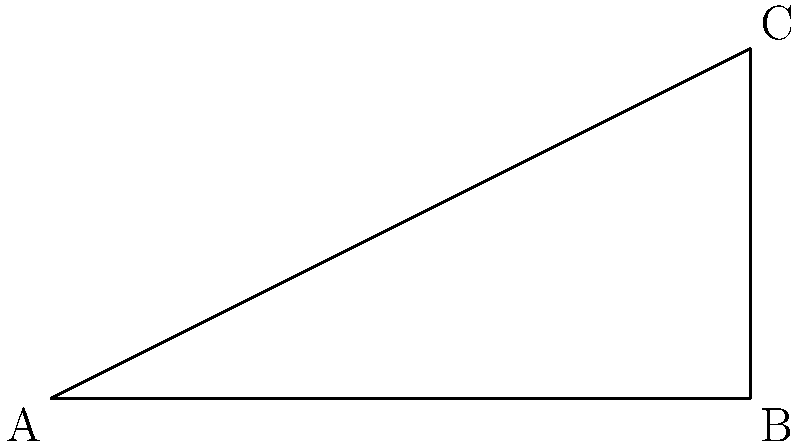From the base of a traditional Bhella tower, you measure a distance of 30 meters to a point on the ground. From this point, the angle of elevation to the top of the tower is $\theta$. If the height of the tower is 20 meters, what is the value of $\theta$ in degrees? Let's approach this step-by-step:

1) We can represent this scenario as a right-angled triangle, where:
   - The base of the triangle is 30 meters (the distance on the ground)
   - The height of the triangle is 20 meters (the height of the tower)
   - The angle we're looking for is $\theta$

2) In a right-angled triangle, we can use the tangent function to find an angle when we know the opposite and adjacent sides.

3) In this case:
   - The opposite side is the height of the tower (20 m)
   - The adjacent side is the distance on the ground (30 m)

4) The formula for tangent is:

   $\tan(\theta) = \frac{\text{opposite}}{\text{adjacent}}$

5) Substituting our values:

   $\tan(\theta) = \frac{20}{30} = \frac{2}{3}$

6) To find $\theta$, we need to use the inverse tangent (arctan or $\tan^{-1}$):

   $\theta = \tan^{-1}(\frac{2}{3})$

7) Using a calculator or trigonometric tables:

   $\theta \approx 33.69^\circ$

Therefore, the angle of elevation to the top of the traditional Bhella tower is approximately 33.69 degrees.
Answer: $33.69^\circ$ 